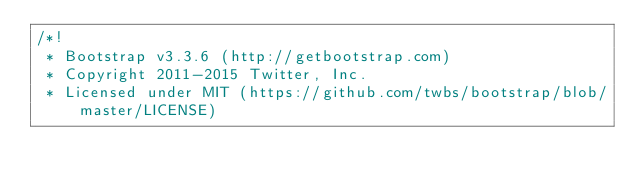<code> <loc_0><loc_0><loc_500><loc_500><_CSS_>/*!
 * Bootstrap v3.3.6 (http://getbootstrap.com)
 * Copyright 2011-2015 Twitter, Inc.
 * Licensed under MIT (https://github.com/twbs/bootstrap/blob/master/LICENSE)</code> 